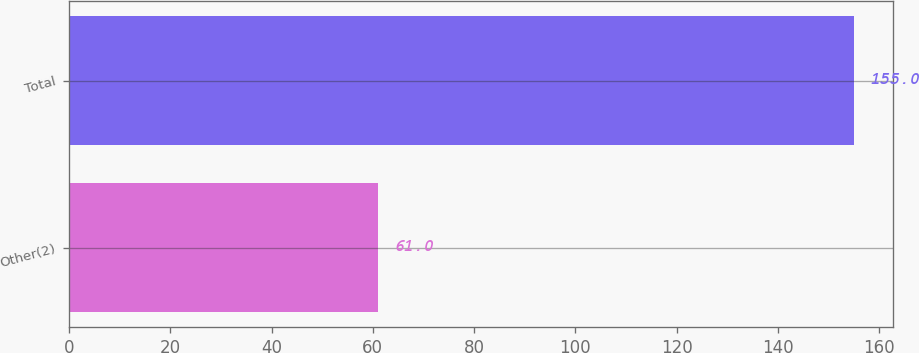Convert chart to OTSL. <chart><loc_0><loc_0><loc_500><loc_500><bar_chart><fcel>Other(2)<fcel>Total<nl><fcel>61<fcel>155<nl></chart> 